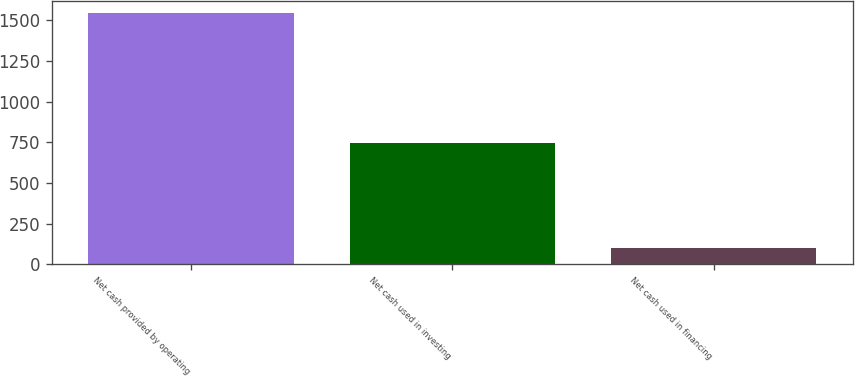<chart> <loc_0><loc_0><loc_500><loc_500><bar_chart><fcel>Net cash provided by operating<fcel>Net cash used in investing<fcel>Net cash used in financing<nl><fcel>1542<fcel>743<fcel>102<nl></chart> 